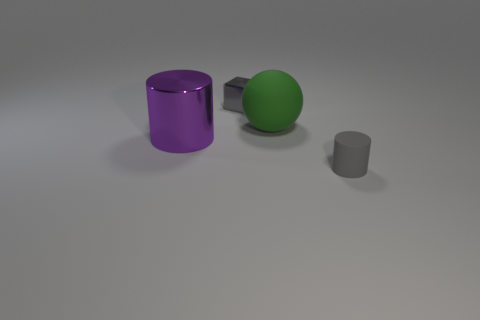What is the color of the object that is both in front of the green ball and on the left side of the big green matte ball?
Your answer should be compact. Purple. Are there more small gray objects behind the large ball than gray objects?
Offer a very short reply. No. Are any green rubber balls visible?
Offer a very short reply. Yes. Does the matte cylinder have the same color as the shiny block?
Ensure brevity in your answer.  Yes. How many big objects are either purple cylinders or brown metallic cubes?
Your response must be concise. 1. Is there anything else that has the same color as the tiny cylinder?
Make the answer very short. Yes. There is a object that is the same material as the small block; what is its shape?
Make the answer very short. Cylinder. There is a rubber thing behind the large purple shiny object; what size is it?
Your answer should be very brief. Large. The big green thing is what shape?
Your answer should be very brief. Sphere. There is a matte object that is on the left side of the gray rubber thing; is its size the same as the metallic thing in front of the green matte sphere?
Your answer should be very brief. Yes. 